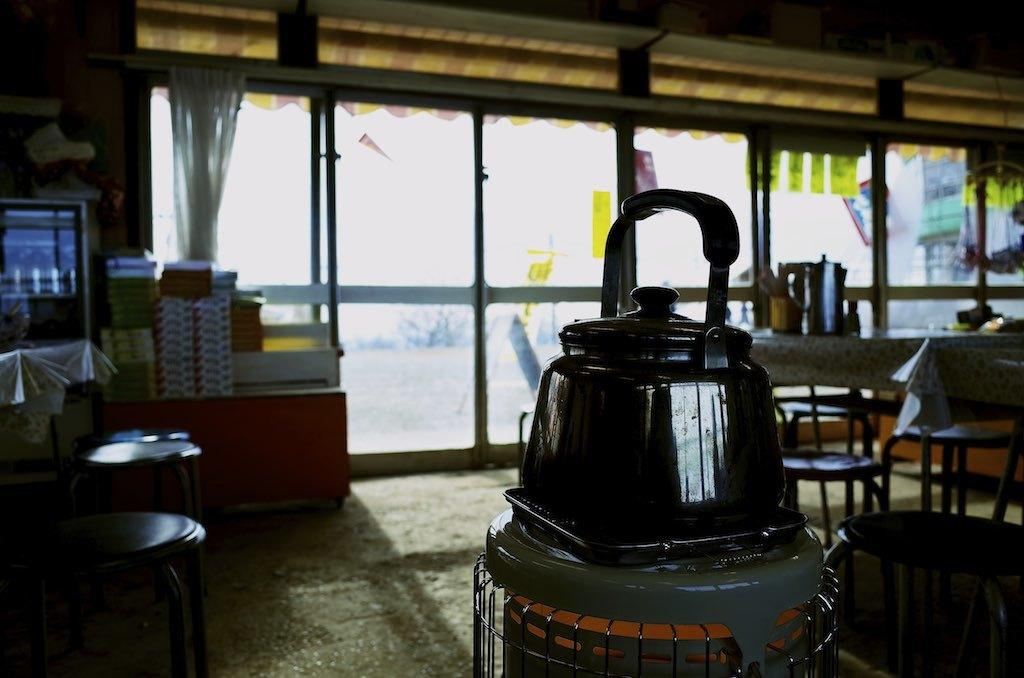What is on the table in the image? There is a coffee kettle on the table. What else can be seen in the background of the image? There are unoccupied chairs in the background. What type of wood is used to make the coffee kettle in the image? The coffee kettle in the image is not made of wood; it is likely made of metal or another material. What shape is the seed that is visible in the image? There is no seed present in the image. 